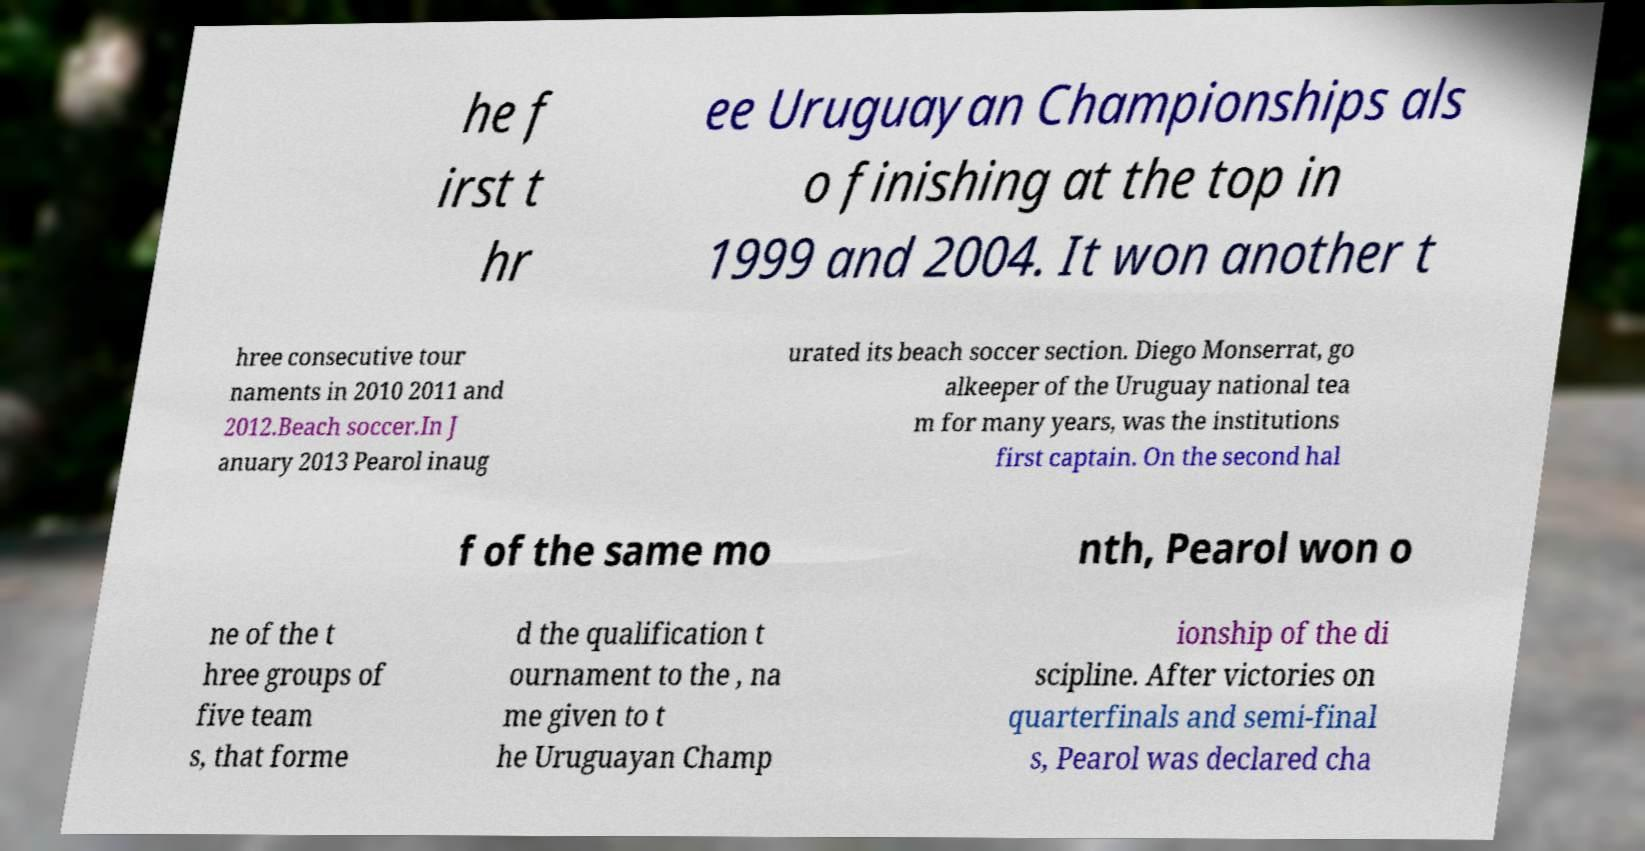There's text embedded in this image that I need extracted. Can you transcribe it verbatim? he f irst t hr ee Uruguayan Championships als o finishing at the top in 1999 and 2004. It won another t hree consecutive tour naments in 2010 2011 and 2012.Beach soccer.In J anuary 2013 Pearol inaug urated its beach soccer section. Diego Monserrat, go alkeeper of the Uruguay national tea m for many years, was the institutions first captain. On the second hal f of the same mo nth, Pearol won o ne of the t hree groups of five team s, that forme d the qualification t ournament to the , na me given to t he Uruguayan Champ ionship of the di scipline. After victories on quarterfinals and semi-final s, Pearol was declared cha 